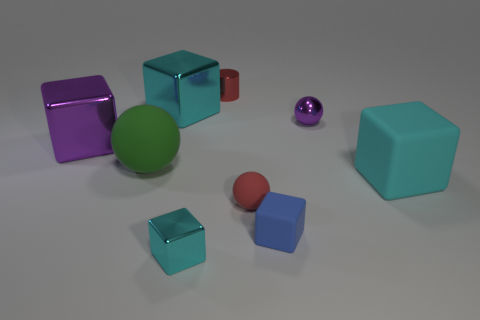What is the shape of the object that is in front of the small blue matte block?
Provide a short and direct response. Cube. Are there the same number of purple shiny objects on the right side of the metal cylinder and big shiny cubes that are left of the large purple object?
Ensure brevity in your answer.  No. What number of things are small rubber things or big things that are on the left side of the blue thing?
Provide a succinct answer. 5. What is the shape of the object that is both behind the purple metal block and left of the tiny cylinder?
Ensure brevity in your answer.  Cube. What is the large cube that is to the right of the red object that is behind the large purple object made of?
Offer a terse response. Rubber. Does the big cyan cube in front of the big matte ball have the same material as the blue thing?
Give a very brief answer. Yes. There is a cyan metallic object that is to the left of the tiny cyan thing; how big is it?
Your response must be concise. Large. There is a tiny shiny thing behind the tiny metallic sphere; are there any small metal cylinders that are in front of it?
Ensure brevity in your answer.  No. Do the small metal thing that is in front of the purple metal block and the large rubber thing that is left of the large matte block have the same color?
Your answer should be compact. No. The cylinder has what color?
Keep it short and to the point. Red. 